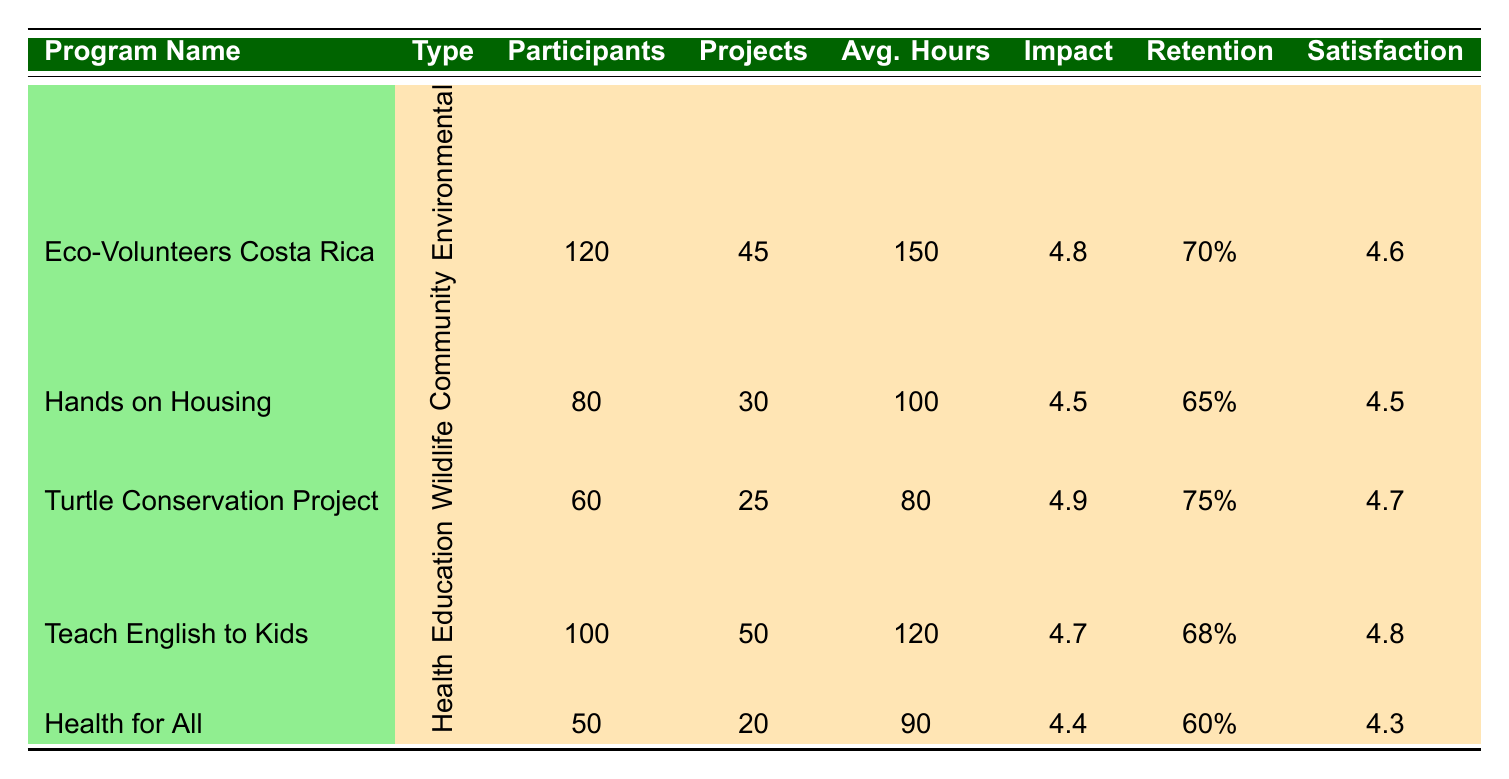What is the program with the highest Community Impact Score? The highest Community Impact Score among all the programs listed is 4.9. This score belongs to the Turtle Conservation Project.
Answer: Turtle Conservation Project How many participants were involved in the Eco-Volunteers Costa Rica program? The table indicates that the Eco-Volunteers Costa Rica program had 120 participants.
Answer: 120 What is the average retention rate of all the programs combined? The retention rates for the programs are 70, 65, 75, 68, and 60. We sum these rates: (70 + 65 + 75 + 68 + 60) = 338. Then, we divide by the number of programs (5) to find the average: 338 / 5 = 67.6.
Answer: 67.6 Did the Teach English to Kids program have a higher Satisfaction Rating than the Health for All program? The Satisfaction Rating for the Teach English to Kids program is 4.8, while the rating for Health for All is 4.3. Since 4.8 is greater than 4.3, the answer is yes.
Answer: Yes How many total projects were completed across all programs? The number of projects completed for each program is: 45 (Eco-Volunteers) + 30 (Hands on Housing) + 25 (Turtle Conservation) + 50 (Teach English) + 20 (Health for All) = 170. So, the total number of projects completed across all programs is 170.
Answer: 170 Which program had the lowest average hours donated? The table shows the Average Hours Donated as follows: 150 (Eco-Volunteers), 100 (Hands on Housing), 80 (Turtle Conservation), 120 (Teach English), and 90 (Health for All). The lowest average is 80 from the Turtle Conservation Project.
Answer: Turtle Conservation Project Is the Volunteer Retention Rate for Hands on Housing greater than that of Health for All? The Volunteer Retention Rate for Hands on Housing is 65%, and for Health for All, it is 60%. Since 65 is greater than 60, the answer is yes.
Answer: Yes What program type had the most participants? Looking at the participant counts: Environmental Conservation (120), Community Development (80), Wildlife Protection (60), Education (100), and Health Services (50). The highest is 120 from the Environmental Conservation type, specifically the Eco-Volunteers Costa Rica program.
Answer: Environmental Conservation What is the difference in Satisfaction Ratings between the highest and lowest rated programs? The highest Satisfaction Rating is 4.8 (Teach English to Kids) and the lowest is 4.3 (Health for All). The difference is: 4.8 - 4.3 = 0.5.
Answer: 0.5 